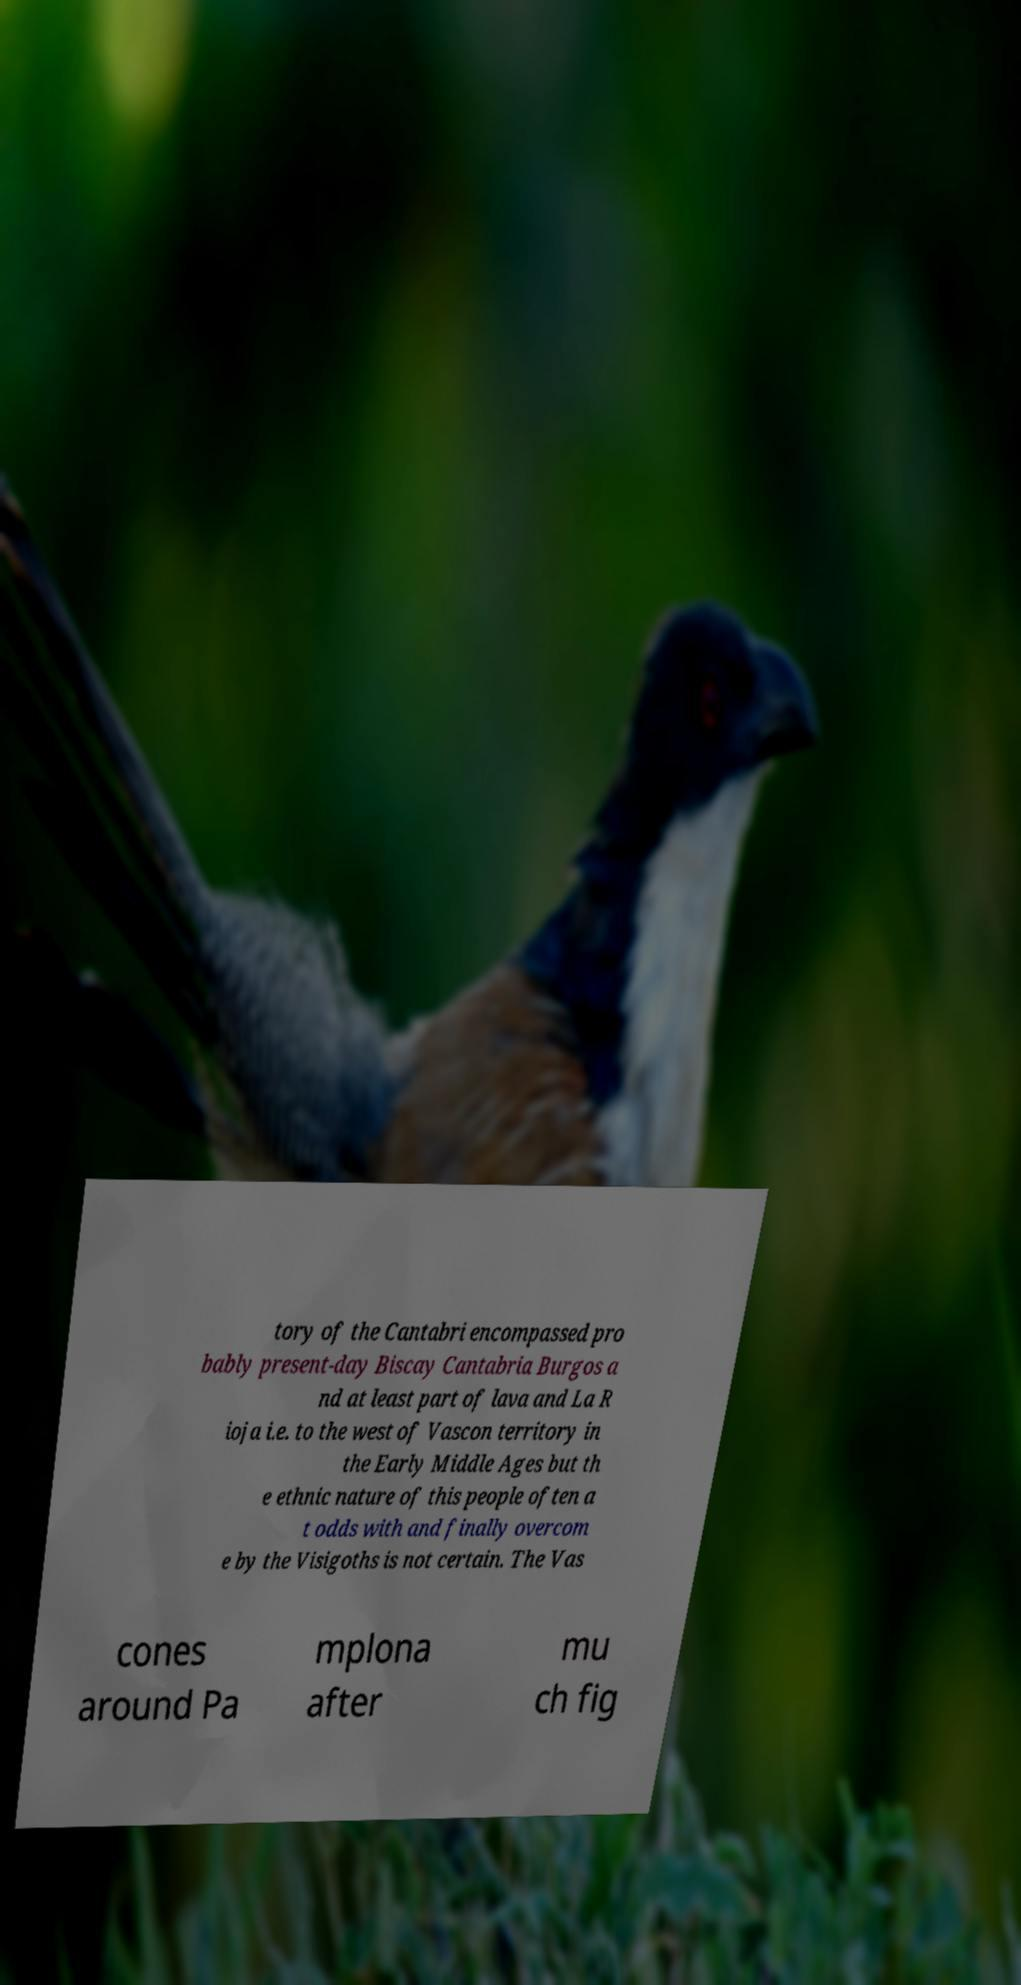Please identify and transcribe the text found in this image. tory of the Cantabri encompassed pro bably present-day Biscay Cantabria Burgos a nd at least part of lava and La R ioja i.e. to the west of Vascon territory in the Early Middle Ages but th e ethnic nature of this people often a t odds with and finally overcom e by the Visigoths is not certain. The Vas cones around Pa mplona after mu ch fig 